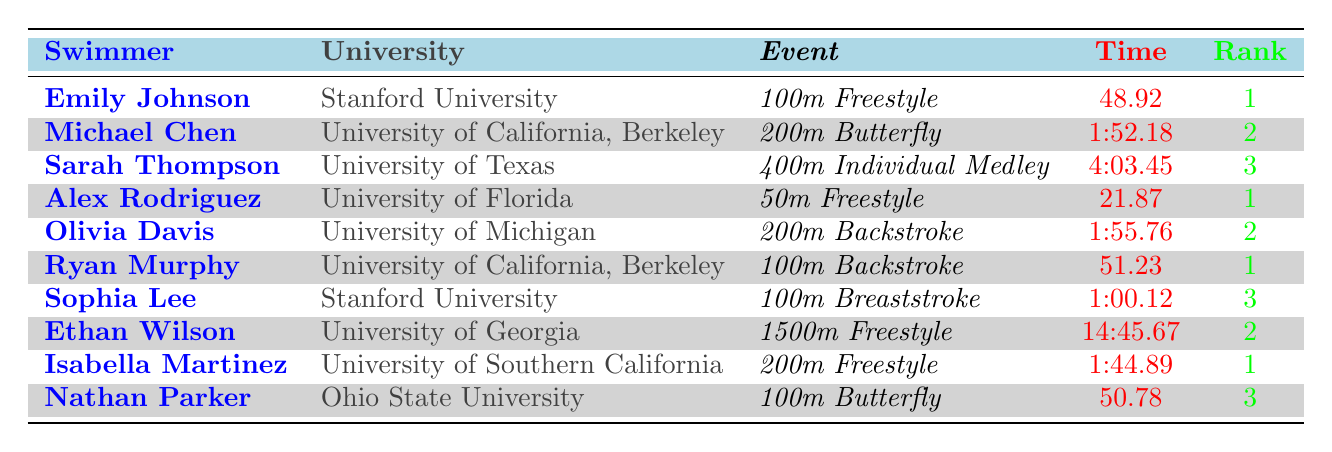What is the best time recorded in the 100m Freestyle? From the table, Emily Johnson achieved a time of 48.92 in the 100m Freestyle, which is the fastest time listed.
Answer: 48.92 Which swimmer from Stanford University has the highest rank? Emily Johnson is from Stanford University and has a rank of 1, which is the highest rank among all swimmers listed from Stanford.
Answer: Emily Johnson Is there a swimmer ranked 3 in the 50m Freestyle? The table does not list any swimmer ranked 3 in the 50m Freestyle event; only Alex Rodriguez and his rank of 1 is mentioned.
Answer: No What is the average time for swimmers from University of California, Berkeley? The times for University of California, Berkeley are 1:52.18 for Michael Chen (200m Butterfly) and 51.23 for Ryan Murphy (100m Backstroke). First, convert 1:52.18 to seconds (112.18 seconds), and the average is (112.18 + 51.23) / 2 = 81.725 seconds, which is approximately 1:21.73 when converted back to minutes and seconds.
Answer: 1:21.73 Which university has the most swimmers with a rank of 1? From the table, both Stanford University and University of Southern California have swimmers ranked 1 (Emily Johnson and Isabella Martinez). Therefore, the universities tied for the highest number of swimmers with that rank.
Answer: Tied: Stanford University and University of Southern California What event does Ryan Murphy compete in? The table shows that Ryan Murphy competes in the 100m Backstroke event as indicated in the data provided.
Answer: 100m Backstroke How many swimmers have recorded times under 1:50 in any event? Checking the table, only one swimmer, Isabella Martinez, has a time under 1:50 in the 200m Freestyle. Thus, the answer is only one swimmer recorded a time under this threshold.
Answer: 1 Is there a swimmer from the University of Florida who ranks lower than 3? The only swimmer from University of Florida listed is Alex Rodriguez, who has a rank of 1. Therefore, there is no swimmer from that university ranked lower than 3.
Answer: No 